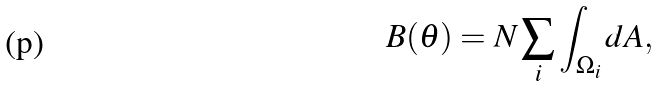Convert formula to latex. <formula><loc_0><loc_0><loc_500><loc_500>B ( \theta ) = N \sum _ { i } \int _ { \Omega _ { i } } d A ,</formula> 